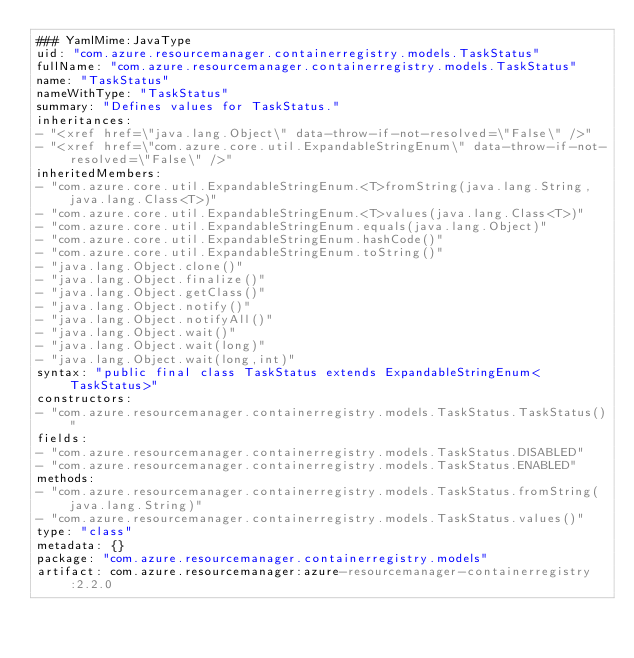<code> <loc_0><loc_0><loc_500><loc_500><_YAML_>### YamlMime:JavaType
uid: "com.azure.resourcemanager.containerregistry.models.TaskStatus"
fullName: "com.azure.resourcemanager.containerregistry.models.TaskStatus"
name: "TaskStatus"
nameWithType: "TaskStatus"
summary: "Defines values for TaskStatus."
inheritances:
- "<xref href=\"java.lang.Object\" data-throw-if-not-resolved=\"False\" />"
- "<xref href=\"com.azure.core.util.ExpandableStringEnum\" data-throw-if-not-resolved=\"False\" />"
inheritedMembers:
- "com.azure.core.util.ExpandableStringEnum.<T>fromString(java.lang.String,java.lang.Class<T>)"
- "com.azure.core.util.ExpandableStringEnum.<T>values(java.lang.Class<T>)"
- "com.azure.core.util.ExpandableStringEnum.equals(java.lang.Object)"
- "com.azure.core.util.ExpandableStringEnum.hashCode()"
- "com.azure.core.util.ExpandableStringEnum.toString()"
- "java.lang.Object.clone()"
- "java.lang.Object.finalize()"
- "java.lang.Object.getClass()"
- "java.lang.Object.notify()"
- "java.lang.Object.notifyAll()"
- "java.lang.Object.wait()"
- "java.lang.Object.wait(long)"
- "java.lang.Object.wait(long,int)"
syntax: "public final class TaskStatus extends ExpandableStringEnum<TaskStatus>"
constructors:
- "com.azure.resourcemanager.containerregistry.models.TaskStatus.TaskStatus()"
fields:
- "com.azure.resourcemanager.containerregistry.models.TaskStatus.DISABLED"
- "com.azure.resourcemanager.containerregistry.models.TaskStatus.ENABLED"
methods:
- "com.azure.resourcemanager.containerregistry.models.TaskStatus.fromString(java.lang.String)"
- "com.azure.resourcemanager.containerregistry.models.TaskStatus.values()"
type: "class"
metadata: {}
package: "com.azure.resourcemanager.containerregistry.models"
artifact: com.azure.resourcemanager:azure-resourcemanager-containerregistry:2.2.0
</code> 